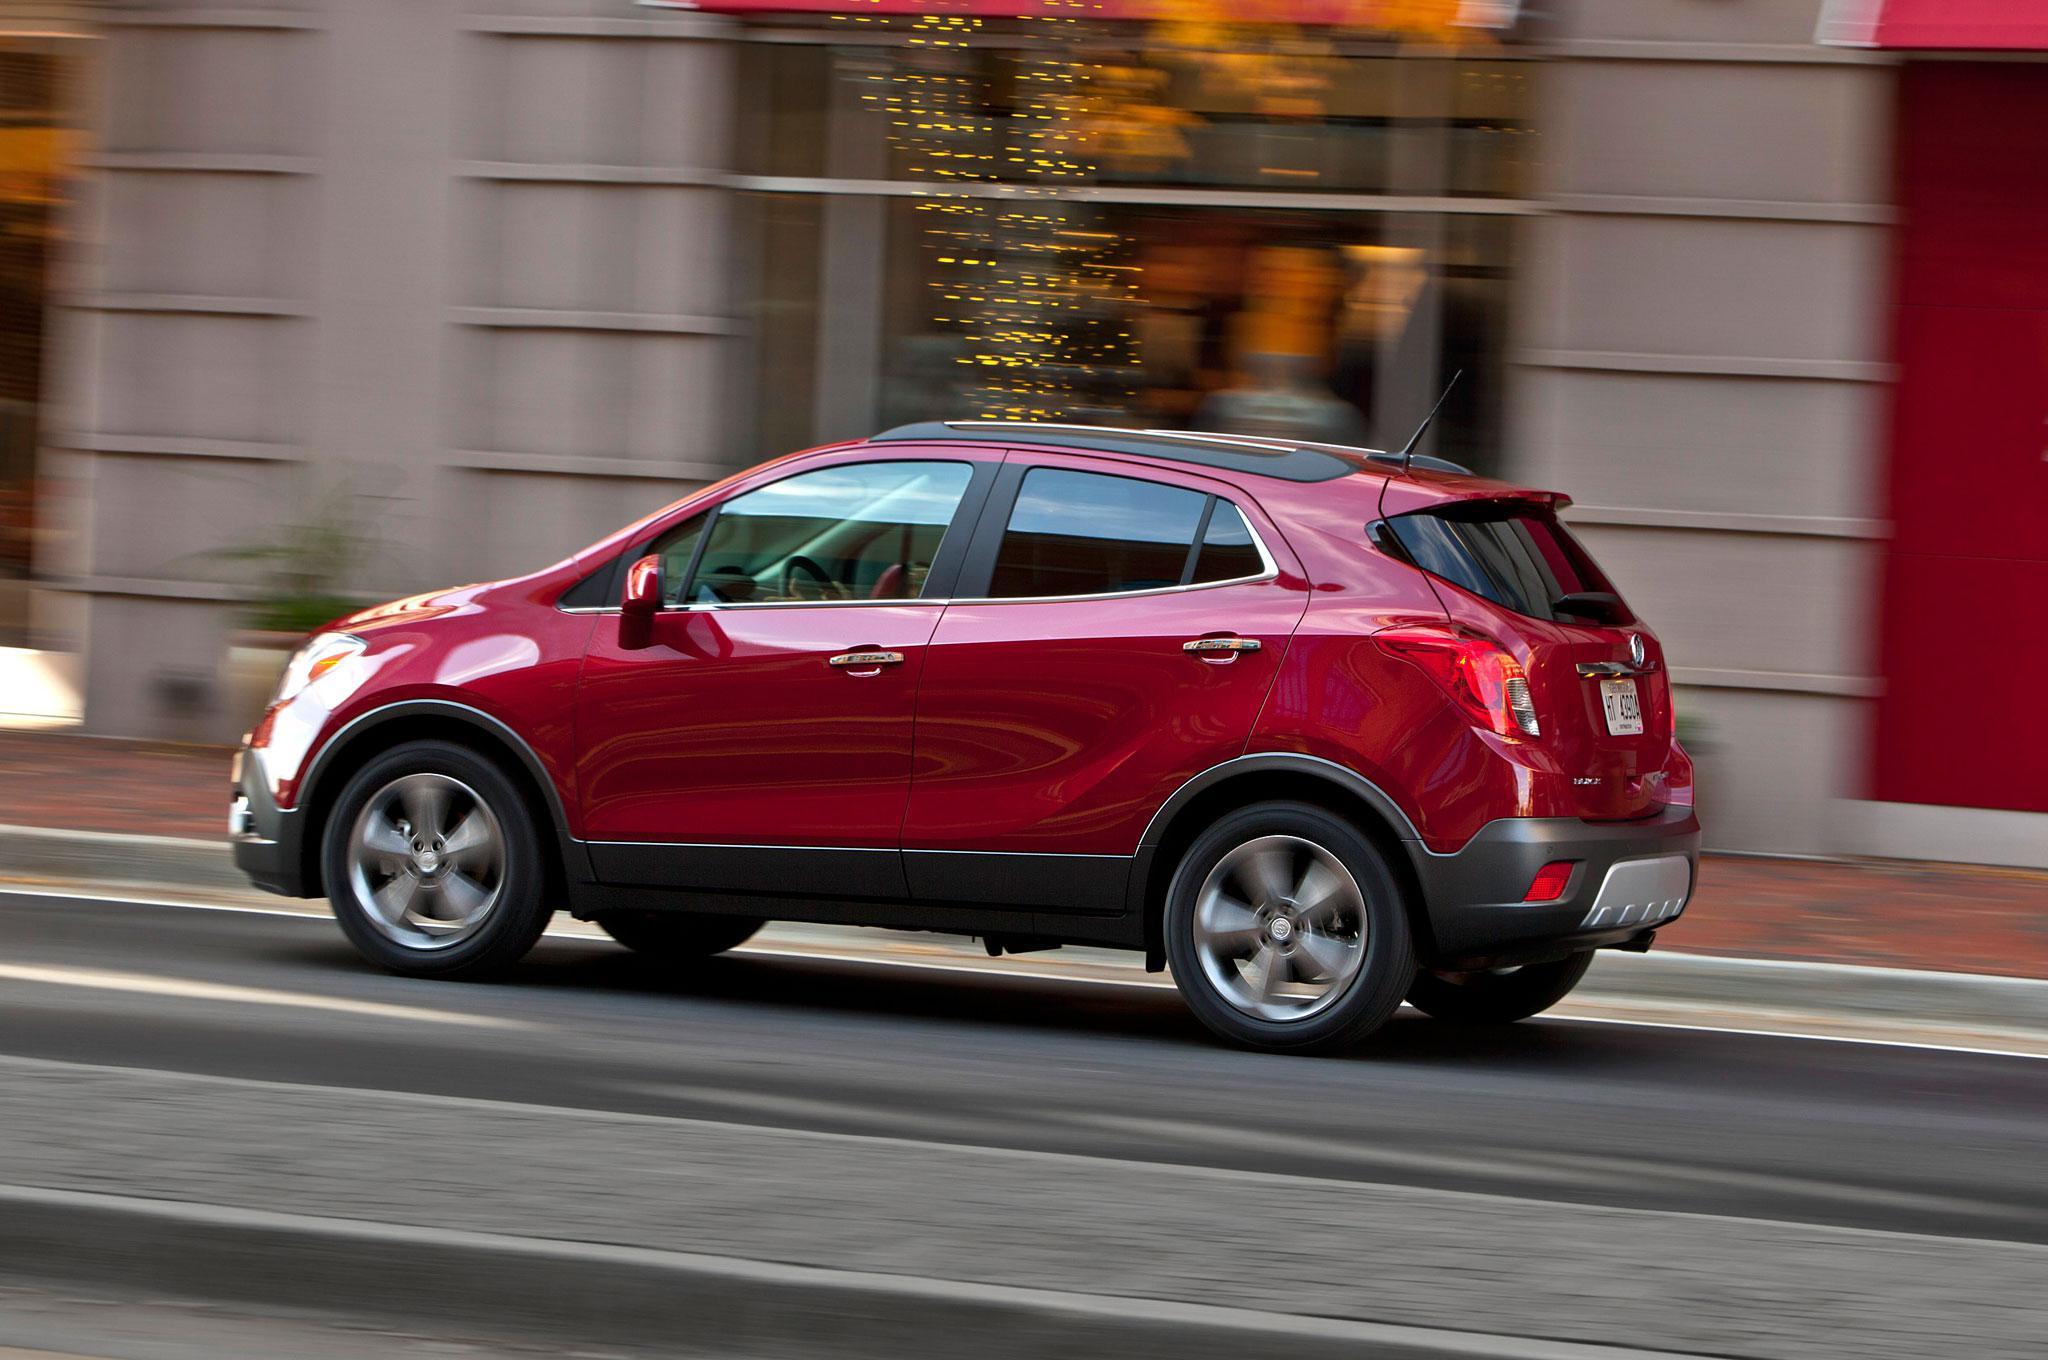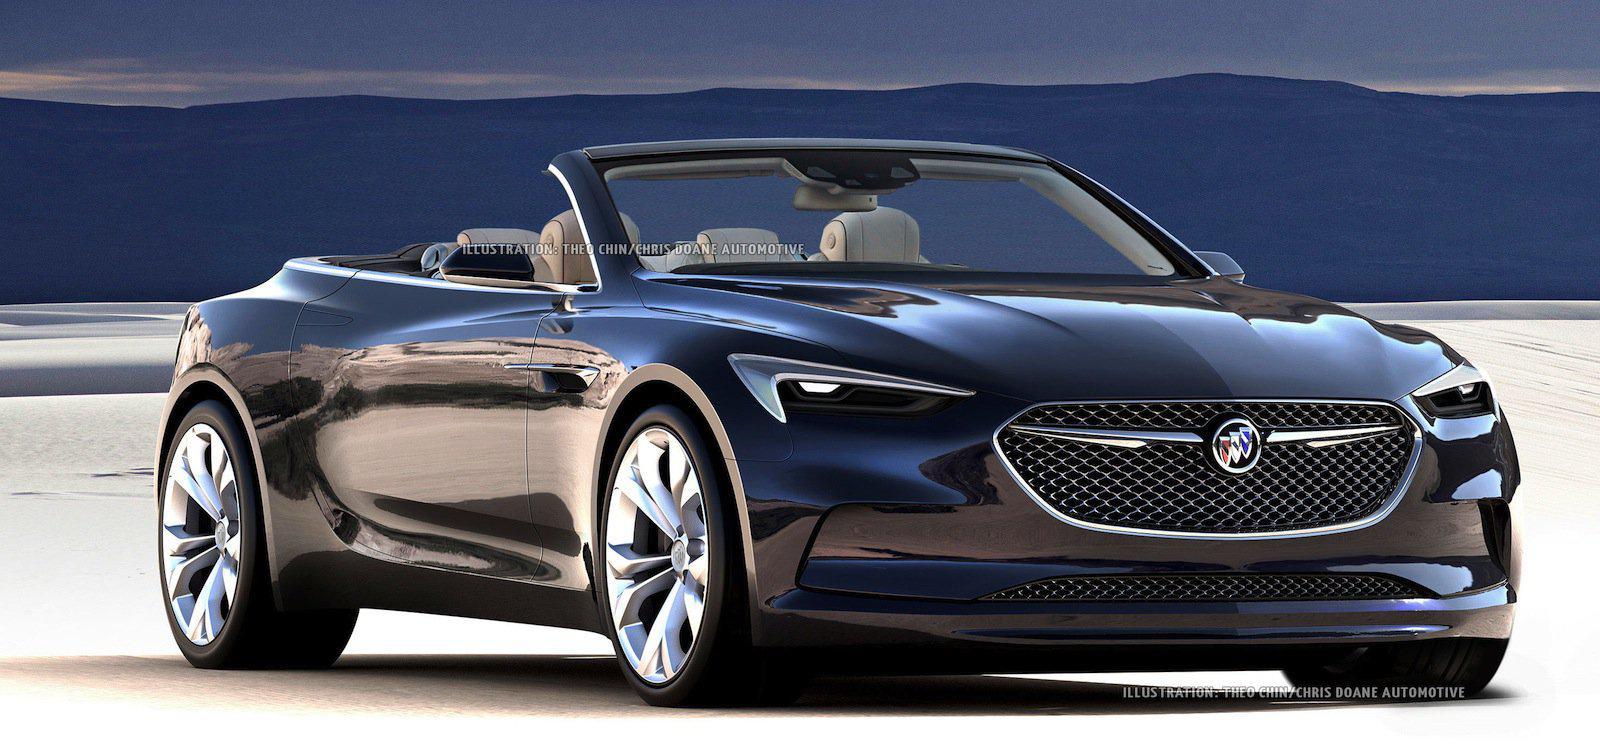The first image is the image on the left, the second image is the image on the right. Examine the images to the left and right. Is the description "Each image contains a single blue convertible with its top down, and at least one has a driver." accurate? Answer yes or no. No. The first image is the image on the left, the second image is the image on the right. Considering the images on both sides, is "There is more than one person in the car in the image on the right." valid? Answer yes or no. No. 